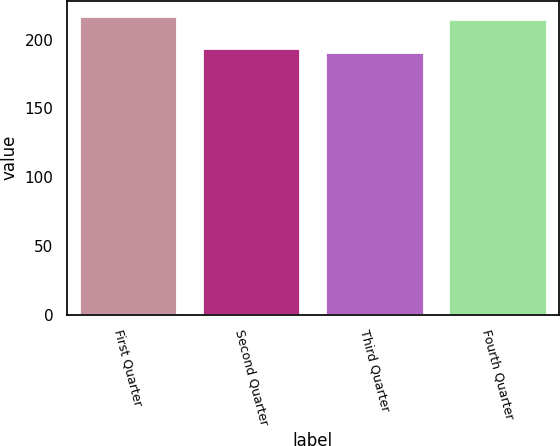Convert chart to OTSL. <chart><loc_0><loc_0><loc_500><loc_500><bar_chart><fcel>First Quarter<fcel>Second Quarter<fcel>Third Quarter<fcel>Fourth Quarter<nl><fcel>217.54<fcel>193.76<fcel>191<fcel>215<nl></chart> 